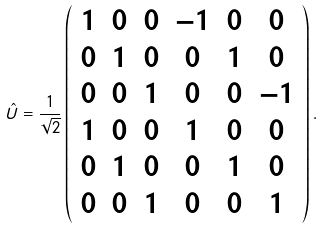Convert formula to latex. <formula><loc_0><loc_0><loc_500><loc_500>\hat { U } = \frac { 1 } { \sqrt { 2 } } \left ( \begin{array} { c c c c c c } 1 & 0 & 0 & - 1 & 0 & 0 \\ 0 & 1 & 0 & 0 & 1 & 0 \\ 0 & 0 & 1 & 0 & 0 & - 1 \\ 1 & 0 & 0 & 1 & 0 & 0 \\ 0 & 1 & 0 & 0 & 1 & 0 \\ 0 & 0 & 1 & 0 & 0 & 1 \\ \end{array} \right ) .</formula> 